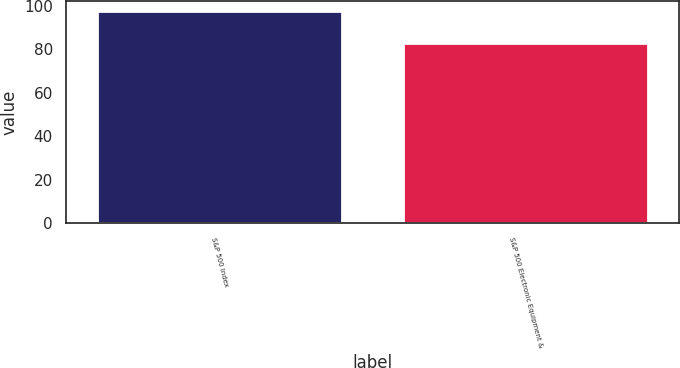<chart> <loc_0><loc_0><loc_500><loc_500><bar_chart><fcel>S&P 500 Index<fcel>S&P 500 Electronic Equipment &<nl><fcel>97.33<fcel>82.81<nl></chart> 